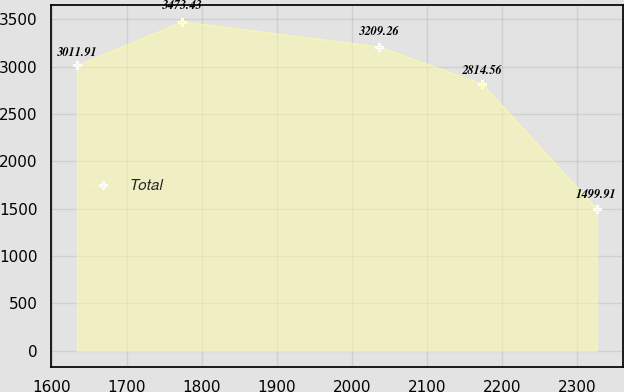Convert chart. <chart><loc_0><loc_0><loc_500><loc_500><line_chart><ecel><fcel>Total<nl><fcel>1633.79<fcel>3011.91<nl><fcel>1774.02<fcel>3473.43<nl><fcel>2036.01<fcel>3209.26<nl><fcel>2173.45<fcel>2814.56<nl><fcel>2325.53<fcel>1499.91<nl></chart> 